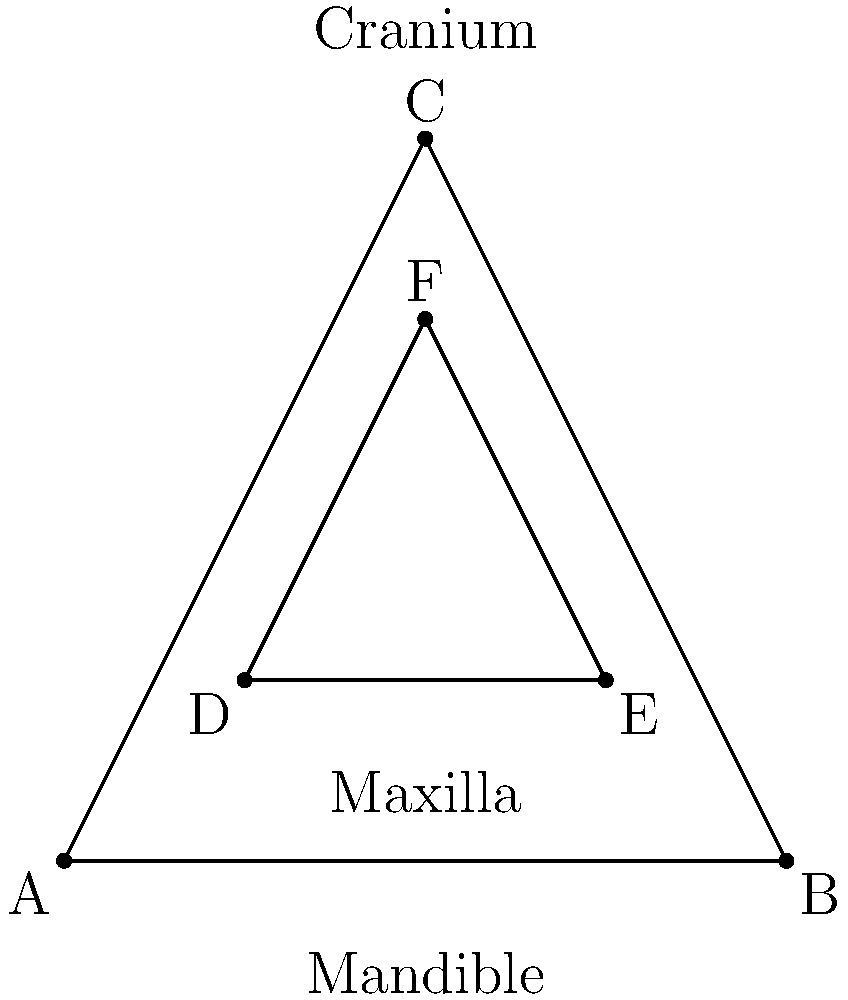In the anatomical diagram of a human skull shown above, which triangle (ABC or DEF) represents the facial region, and what is the significance of this area in archaeological analysis of skeletal remains? To answer this question, let's follow these steps:

1. Identify the triangles:
   - Triangle ABC represents the overall skull shape
   - Triangle DEF represents the facial region

2. Recognize the labeled parts:
   - The cranium is labeled at the top
   - The mandible (lower jaw) is labeled at the bottom
   - The maxilla (upper jaw) is labeled in the middle

3. Understand the significance of the facial region (Triangle DEF):
   a) Age estimation: The development and wear of teeth in the maxilla and mandible can indicate age.
   b) Ancestry determination: The shape and features of the facial bones can provide clues about ancestral origins.
   c) Sex determination: Differences in robusticity and size of facial features can help determine sex.
   d) Diet analysis: Tooth wear patterns and isotope analysis of dental remains can reveal dietary habits.
   e) Health assessment: Dental pathologies and bone abnormalities in the facial region can indicate health issues.
   f) Facial reconstruction: The facial bones serve as the foundation for creating facial approximations of individuals.

4. Importance in archaeological context:
   - Facial features are crucial for individual identification and population studies.
   - They provide valuable information about past societies' demographics, health, and cultural practices.

Therefore, Triangle DEF represents the facial region, which is significant for its multifaceted role in archaeological analysis of skeletal remains.
Answer: Triangle DEF; crucial for age, ancestry, sex determination, diet analysis, health assessment, and facial reconstruction in archaeological studies. 